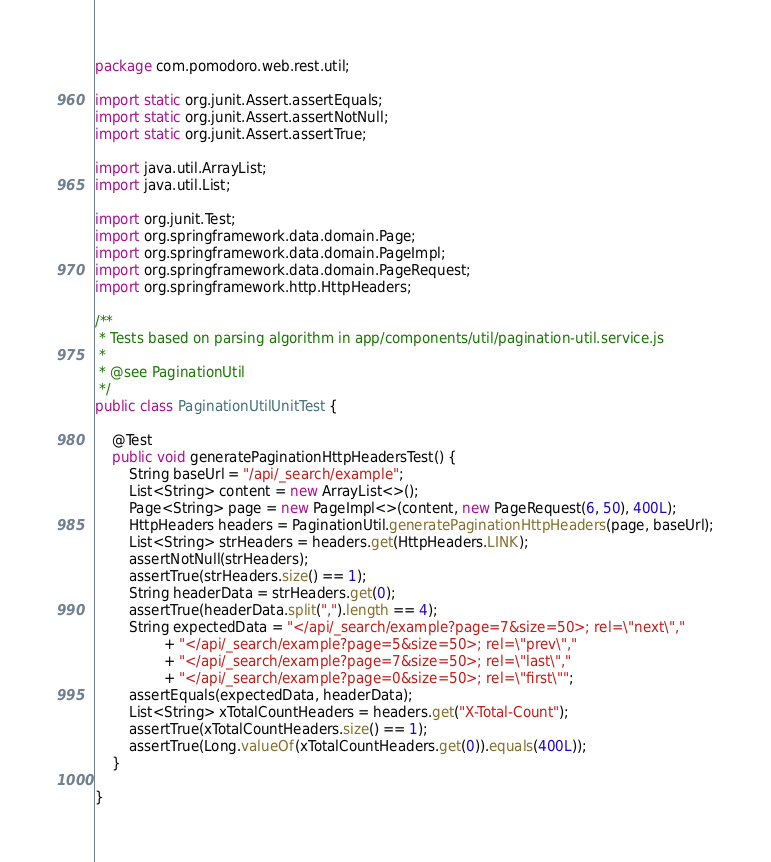<code> <loc_0><loc_0><loc_500><loc_500><_Java_>package com.pomodoro.web.rest.util;

import static org.junit.Assert.assertEquals;
import static org.junit.Assert.assertNotNull;
import static org.junit.Assert.assertTrue;

import java.util.ArrayList;
import java.util.List;

import org.junit.Test;
import org.springframework.data.domain.Page;
import org.springframework.data.domain.PageImpl;
import org.springframework.data.domain.PageRequest;
import org.springframework.http.HttpHeaders;

/**
 * Tests based on parsing algorithm in app/components/util/pagination-util.service.js
 *
 * @see PaginationUtil
 */
public class PaginationUtilUnitTest {

    @Test
    public void generatePaginationHttpHeadersTest() {
        String baseUrl = "/api/_search/example";
        List<String> content = new ArrayList<>();
        Page<String> page = new PageImpl<>(content, new PageRequest(6, 50), 400L);
        HttpHeaders headers = PaginationUtil.generatePaginationHttpHeaders(page, baseUrl);
        List<String> strHeaders = headers.get(HttpHeaders.LINK);
        assertNotNull(strHeaders);
        assertTrue(strHeaders.size() == 1);
        String headerData = strHeaders.get(0);
        assertTrue(headerData.split(",").length == 4);
        String expectedData = "</api/_search/example?page=7&size=50>; rel=\"next\","
                + "</api/_search/example?page=5&size=50>; rel=\"prev\","
                + "</api/_search/example?page=7&size=50>; rel=\"last\","
                + "</api/_search/example?page=0&size=50>; rel=\"first\"";
        assertEquals(expectedData, headerData);
        List<String> xTotalCountHeaders = headers.get("X-Total-Count");
        assertTrue(xTotalCountHeaders.size() == 1);
        assertTrue(Long.valueOf(xTotalCountHeaders.get(0)).equals(400L));
    }

}
</code> 